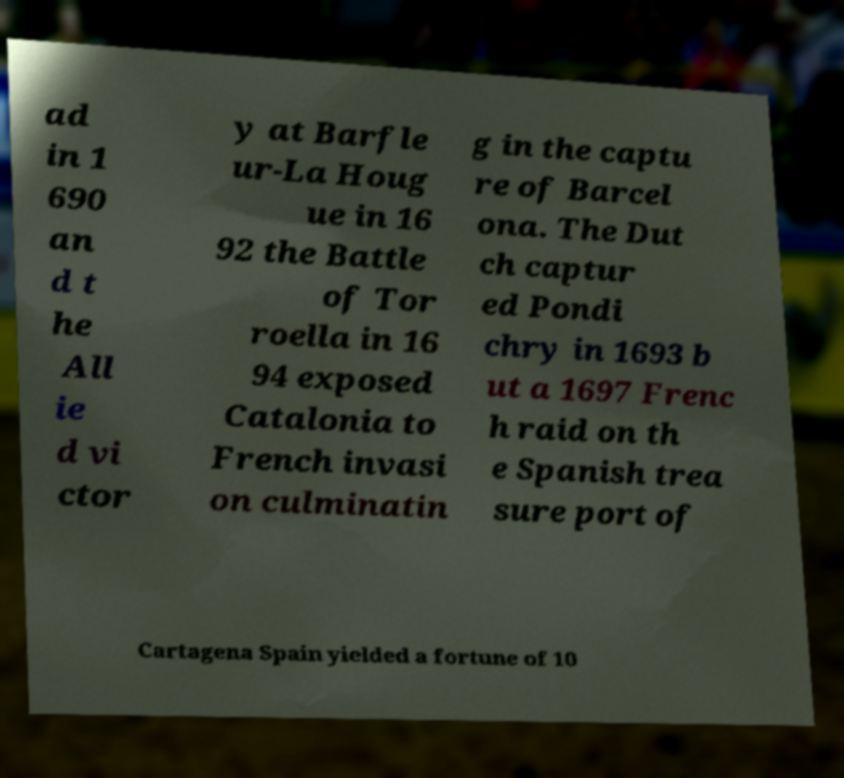What messages or text are displayed in this image? I need them in a readable, typed format. ad in 1 690 an d t he All ie d vi ctor y at Barfle ur-La Houg ue in 16 92 the Battle of Tor roella in 16 94 exposed Catalonia to French invasi on culminatin g in the captu re of Barcel ona. The Dut ch captur ed Pondi chry in 1693 b ut a 1697 Frenc h raid on th e Spanish trea sure port of Cartagena Spain yielded a fortune of 10 